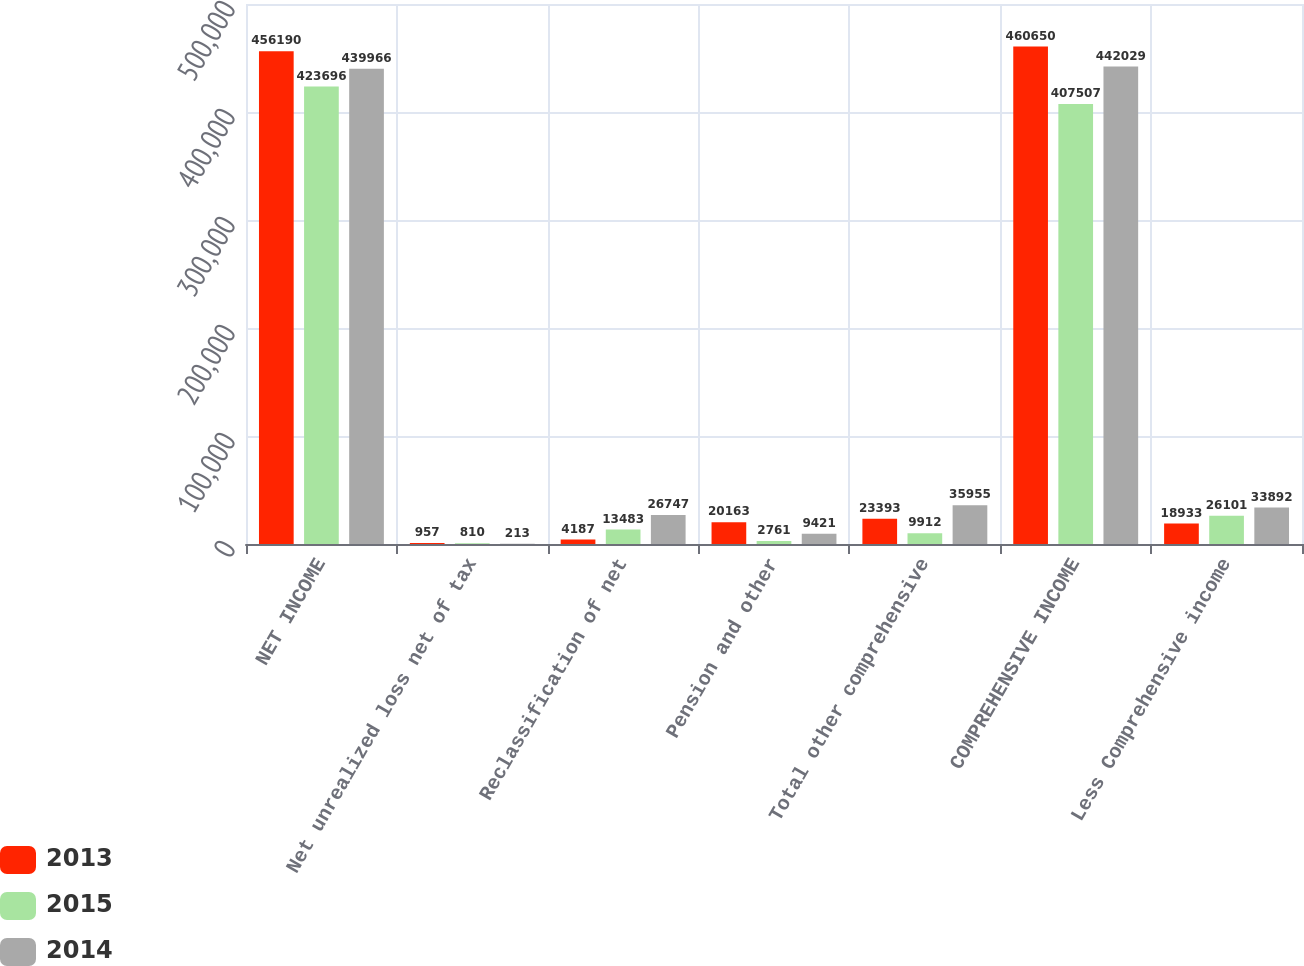Convert chart to OTSL. <chart><loc_0><loc_0><loc_500><loc_500><stacked_bar_chart><ecel><fcel>NET INCOME<fcel>Net unrealized loss net of tax<fcel>Reclassification of net<fcel>Pension and other<fcel>Total other comprehensive<fcel>COMPREHENSIVE INCOME<fcel>Less Comprehensive income<nl><fcel>2013<fcel>456190<fcel>957<fcel>4187<fcel>20163<fcel>23393<fcel>460650<fcel>18933<nl><fcel>2015<fcel>423696<fcel>810<fcel>13483<fcel>2761<fcel>9912<fcel>407507<fcel>26101<nl><fcel>2014<fcel>439966<fcel>213<fcel>26747<fcel>9421<fcel>35955<fcel>442029<fcel>33892<nl></chart> 